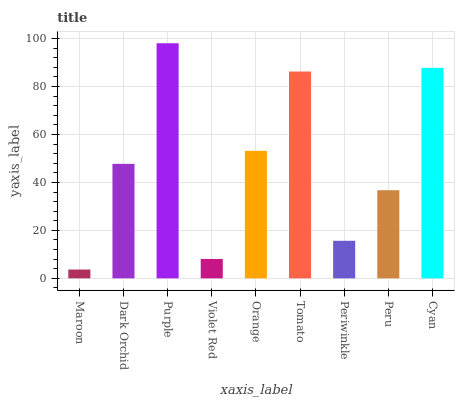Is Maroon the minimum?
Answer yes or no. Yes. Is Purple the maximum?
Answer yes or no. Yes. Is Dark Orchid the minimum?
Answer yes or no. No. Is Dark Orchid the maximum?
Answer yes or no. No. Is Dark Orchid greater than Maroon?
Answer yes or no. Yes. Is Maroon less than Dark Orchid?
Answer yes or no. Yes. Is Maroon greater than Dark Orchid?
Answer yes or no. No. Is Dark Orchid less than Maroon?
Answer yes or no. No. Is Dark Orchid the high median?
Answer yes or no. Yes. Is Dark Orchid the low median?
Answer yes or no. Yes. Is Orange the high median?
Answer yes or no. No. Is Cyan the low median?
Answer yes or no. No. 